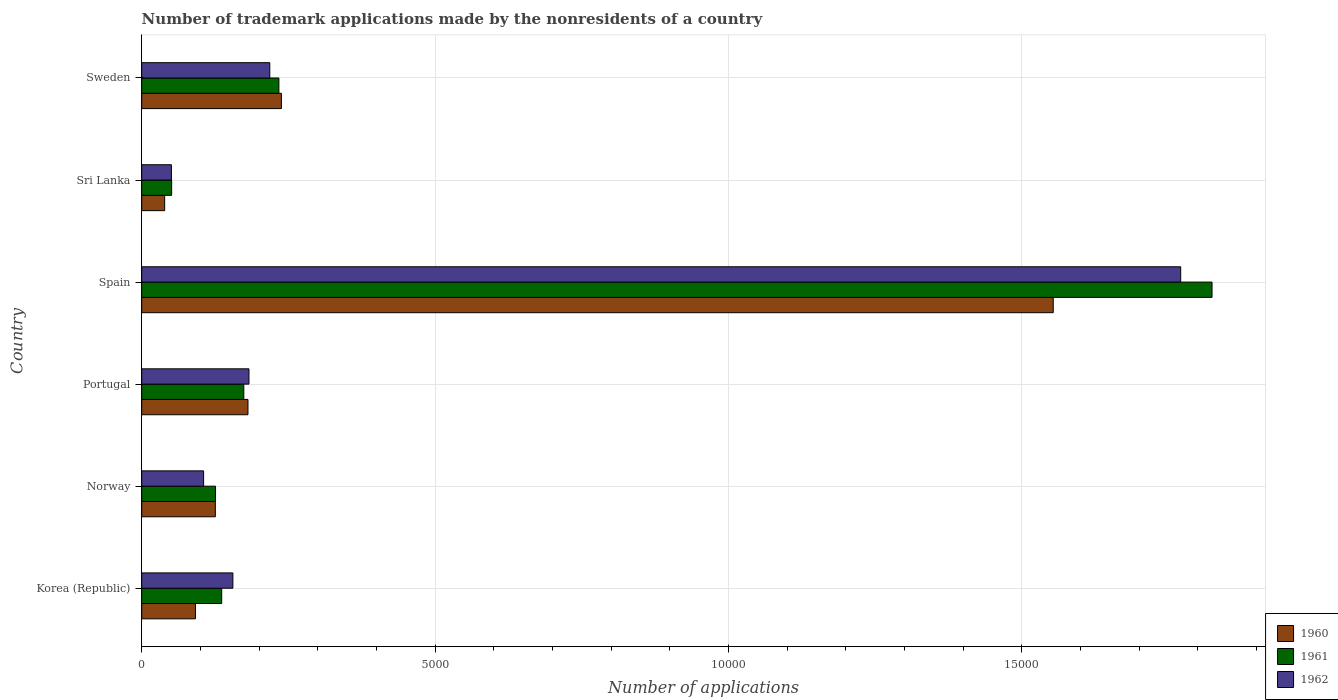How many different coloured bars are there?
Give a very brief answer. 3. How many groups of bars are there?
Your answer should be very brief. 6. Are the number of bars per tick equal to the number of legend labels?
Keep it short and to the point. Yes. Are the number of bars on each tick of the Y-axis equal?
Offer a terse response. Yes. How many bars are there on the 1st tick from the bottom?
Your response must be concise. 3. What is the number of trademark applications made by the nonresidents in 1962 in Sweden?
Make the answer very short. 2183. Across all countries, what is the maximum number of trademark applications made by the nonresidents in 1961?
Provide a short and direct response. 1.82e+04. Across all countries, what is the minimum number of trademark applications made by the nonresidents in 1962?
Offer a terse response. 506. In which country was the number of trademark applications made by the nonresidents in 1960 maximum?
Offer a very short reply. Spain. In which country was the number of trademark applications made by the nonresidents in 1961 minimum?
Your answer should be very brief. Sri Lanka. What is the total number of trademark applications made by the nonresidents in 1960 in the graph?
Ensure brevity in your answer.  2.23e+04. What is the difference between the number of trademark applications made by the nonresidents in 1961 in Norway and that in Spain?
Your answer should be very brief. -1.70e+04. What is the difference between the number of trademark applications made by the nonresidents in 1960 in Sri Lanka and the number of trademark applications made by the nonresidents in 1962 in Sweden?
Provide a short and direct response. -1792. What is the average number of trademark applications made by the nonresidents in 1960 per country?
Keep it short and to the point. 3715.17. What is the difference between the number of trademark applications made by the nonresidents in 1961 and number of trademark applications made by the nonresidents in 1962 in Spain?
Your answer should be very brief. 534. What is the ratio of the number of trademark applications made by the nonresidents in 1961 in Spain to that in Sri Lanka?
Keep it short and to the point. 35.77. Is the number of trademark applications made by the nonresidents in 1961 in Spain less than that in Sweden?
Ensure brevity in your answer.  No. What is the difference between the highest and the second highest number of trademark applications made by the nonresidents in 1961?
Keep it short and to the point. 1.59e+04. What is the difference between the highest and the lowest number of trademark applications made by the nonresidents in 1962?
Make the answer very short. 1.72e+04. What does the 1st bar from the top in Portugal represents?
Ensure brevity in your answer.  1962. What does the 3rd bar from the bottom in Spain represents?
Provide a short and direct response. 1962. Is it the case that in every country, the sum of the number of trademark applications made by the nonresidents in 1960 and number of trademark applications made by the nonresidents in 1962 is greater than the number of trademark applications made by the nonresidents in 1961?
Give a very brief answer. Yes. Are all the bars in the graph horizontal?
Your answer should be very brief. Yes. How many countries are there in the graph?
Provide a short and direct response. 6. Are the values on the major ticks of X-axis written in scientific E-notation?
Provide a short and direct response. No. Does the graph contain grids?
Keep it short and to the point. Yes. Where does the legend appear in the graph?
Make the answer very short. Bottom right. How are the legend labels stacked?
Offer a terse response. Vertical. What is the title of the graph?
Ensure brevity in your answer.  Number of trademark applications made by the nonresidents of a country. Does "1972" appear as one of the legend labels in the graph?
Make the answer very short. No. What is the label or title of the X-axis?
Your answer should be very brief. Number of applications. What is the Number of applications of 1960 in Korea (Republic)?
Ensure brevity in your answer.  916. What is the Number of applications in 1961 in Korea (Republic)?
Ensure brevity in your answer.  1363. What is the Number of applications of 1962 in Korea (Republic)?
Offer a terse response. 1554. What is the Number of applications of 1960 in Norway?
Your answer should be very brief. 1255. What is the Number of applications of 1961 in Norway?
Provide a succinct answer. 1258. What is the Number of applications in 1962 in Norway?
Give a very brief answer. 1055. What is the Number of applications of 1960 in Portugal?
Provide a succinct answer. 1811. What is the Number of applications of 1961 in Portugal?
Provide a succinct answer. 1740. What is the Number of applications of 1962 in Portugal?
Keep it short and to the point. 1828. What is the Number of applications of 1960 in Spain?
Offer a terse response. 1.55e+04. What is the Number of applications in 1961 in Spain?
Offer a terse response. 1.82e+04. What is the Number of applications in 1962 in Spain?
Keep it short and to the point. 1.77e+04. What is the Number of applications in 1960 in Sri Lanka?
Provide a short and direct response. 391. What is the Number of applications of 1961 in Sri Lanka?
Your answer should be very brief. 510. What is the Number of applications in 1962 in Sri Lanka?
Your answer should be compact. 506. What is the Number of applications of 1960 in Sweden?
Make the answer very short. 2381. What is the Number of applications of 1961 in Sweden?
Provide a succinct answer. 2338. What is the Number of applications in 1962 in Sweden?
Make the answer very short. 2183. Across all countries, what is the maximum Number of applications of 1960?
Ensure brevity in your answer.  1.55e+04. Across all countries, what is the maximum Number of applications in 1961?
Keep it short and to the point. 1.82e+04. Across all countries, what is the maximum Number of applications of 1962?
Provide a succinct answer. 1.77e+04. Across all countries, what is the minimum Number of applications of 1960?
Keep it short and to the point. 391. Across all countries, what is the minimum Number of applications in 1961?
Offer a terse response. 510. Across all countries, what is the minimum Number of applications in 1962?
Provide a short and direct response. 506. What is the total Number of applications in 1960 in the graph?
Offer a terse response. 2.23e+04. What is the total Number of applications in 1961 in the graph?
Make the answer very short. 2.55e+04. What is the total Number of applications of 1962 in the graph?
Provide a short and direct response. 2.48e+04. What is the difference between the Number of applications of 1960 in Korea (Republic) and that in Norway?
Your answer should be very brief. -339. What is the difference between the Number of applications in 1961 in Korea (Republic) and that in Norway?
Ensure brevity in your answer.  105. What is the difference between the Number of applications in 1962 in Korea (Republic) and that in Norway?
Provide a short and direct response. 499. What is the difference between the Number of applications in 1960 in Korea (Republic) and that in Portugal?
Offer a very short reply. -895. What is the difference between the Number of applications in 1961 in Korea (Republic) and that in Portugal?
Offer a very short reply. -377. What is the difference between the Number of applications in 1962 in Korea (Republic) and that in Portugal?
Your answer should be very brief. -274. What is the difference between the Number of applications of 1960 in Korea (Republic) and that in Spain?
Provide a short and direct response. -1.46e+04. What is the difference between the Number of applications of 1961 in Korea (Republic) and that in Spain?
Give a very brief answer. -1.69e+04. What is the difference between the Number of applications of 1962 in Korea (Republic) and that in Spain?
Offer a very short reply. -1.62e+04. What is the difference between the Number of applications in 1960 in Korea (Republic) and that in Sri Lanka?
Give a very brief answer. 525. What is the difference between the Number of applications of 1961 in Korea (Republic) and that in Sri Lanka?
Give a very brief answer. 853. What is the difference between the Number of applications in 1962 in Korea (Republic) and that in Sri Lanka?
Your answer should be compact. 1048. What is the difference between the Number of applications of 1960 in Korea (Republic) and that in Sweden?
Ensure brevity in your answer.  -1465. What is the difference between the Number of applications in 1961 in Korea (Republic) and that in Sweden?
Keep it short and to the point. -975. What is the difference between the Number of applications of 1962 in Korea (Republic) and that in Sweden?
Ensure brevity in your answer.  -629. What is the difference between the Number of applications in 1960 in Norway and that in Portugal?
Ensure brevity in your answer.  -556. What is the difference between the Number of applications in 1961 in Norway and that in Portugal?
Provide a succinct answer. -482. What is the difference between the Number of applications in 1962 in Norway and that in Portugal?
Keep it short and to the point. -773. What is the difference between the Number of applications of 1960 in Norway and that in Spain?
Your answer should be very brief. -1.43e+04. What is the difference between the Number of applications of 1961 in Norway and that in Spain?
Make the answer very short. -1.70e+04. What is the difference between the Number of applications in 1962 in Norway and that in Spain?
Your answer should be very brief. -1.67e+04. What is the difference between the Number of applications of 1960 in Norway and that in Sri Lanka?
Ensure brevity in your answer.  864. What is the difference between the Number of applications of 1961 in Norway and that in Sri Lanka?
Offer a very short reply. 748. What is the difference between the Number of applications of 1962 in Norway and that in Sri Lanka?
Your answer should be compact. 549. What is the difference between the Number of applications of 1960 in Norway and that in Sweden?
Your response must be concise. -1126. What is the difference between the Number of applications of 1961 in Norway and that in Sweden?
Offer a terse response. -1080. What is the difference between the Number of applications of 1962 in Norway and that in Sweden?
Provide a succinct answer. -1128. What is the difference between the Number of applications of 1960 in Portugal and that in Spain?
Ensure brevity in your answer.  -1.37e+04. What is the difference between the Number of applications in 1961 in Portugal and that in Spain?
Make the answer very short. -1.65e+04. What is the difference between the Number of applications of 1962 in Portugal and that in Spain?
Give a very brief answer. -1.59e+04. What is the difference between the Number of applications in 1960 in Portugal and that in Sri Lanka?
Give a very brief answer. 1420. What is the difference between the Number of applications in 1961 in Portugal and that in Sri Lanka?
Your answer should be very brief. 1230. What is the difference between the Number of applications of 1962 in Portugal and that in Sri Lanka?
Give a very brief answer. 1322. What is the difference between the Number of applications in 1960 in Portugal and that in Sweden?
Provide a short and direct response. -570. What is the difference between the Number of applications of 1961 in Portugal and that in Sweden?
Give a very brief answer. -598. What is the difference between the Number of applications of 1962 in Portugal and that in Sweden?
Provide a short and direct response. -355. What is the difference between the Number of applications of 1960 in Spain and that in Sri Lanka?
Ensure brevity in your answer.  1.51e+04. What is the difference between the Number of applications of 1961 in Spain and that in Sri Lanka?
Keep it short and to the point. 1.77e+04. What is the difference between the Number of applications of 1962 in Spain and that in Sri Lanka?
Offer a terse response. 1.72e+04. What is the difference between the Number of applications in 1960 in Spain and that in Sweden?
Offer a terse response. 1.32e+04. What is the difference between the Number of applications of 1961 in Spain and that in Sweden?
Offer a very short reply. 1.59e+04. What is the difference between the Number of applications in 1962 in Spain and that in Sweden?
Keep it short and to the point. 1.55e+04. What is the difference between the Number of applications in 1960 in Sri Lanka and that in Sweden?
Give a very brief answer. -1990. What is the difference between the Number of applications in 1961 in Sri Lanka and that in Sweden?
Offer a very short reply. -1828. What is the difference between the Number of applications in 1962 in Sri Lanka and that in Sweden?
Keep it short and to the point. -1677. What is the difference between the Number of applications of 1960 in Korea (Republic) and the Number of applications of 1961 in Norway?
Make the answer very short. -342. What is the difference between the Number of applications of 1960 in Korea (Republic) and the Number of applications of 1962 in Norway?
Ensure brevity in your answer.  -139. What is the difference between the Number of applications in 1961 in Korea (Republic) and the Number of applications in 1962 in Norway?
Ensure brevity in your answer.  308. What is the difference between the Number of applications in 1960 in Korea (Republic) and the Number of applications in 1961 in Portugal?
Your answer should be very brief. -824. What is the difference between the Number of applications in 1960 in Korea (Republic) and the Number of applications in 1962 in Portugal?
Offer a terse response. -912. What is the difference between the Number of applications of 1961 in Korea (Republic) and the Number of applications of 1962 in Portugal?
Give a very brief answer. -465. What is the difference between the Number of applications of 1960 in Korea (Republic) and the Number of applications of 1961 in Spain?
Give a very brief answer. -1.73e+04. What is the difference between the Number of applications of 1960 in Korea (Republic) and the Number of applications of 1962 in Spain?
Provide a succinct answer. -1.68e+04. What is the difference between the Number of applications in 1961 in Korea (Republic) and the Number of applications in 1962 in Spain?
Provide a succinct answer. -1.63e+04. What is the difference between the Number of applications in 1960 in Korea (Republic) and the Number of applications in 1961 in Sri Lanka?
Give a very brief answer. 406. What is the difference between the Number of applications of 1960 in Korea (Republic) and the Number of applications of 1962 in Sri Lanka?
Offer a terse response. 410. What is the difference between the Number of applications in 1961 in Korea (Republic) and the Number of applications in 1962 in Sri Lanka?
Give a very brief answer. 857. What is the difference between the Number of applications in 1960 in Korea (Republic) and the Number of applications in 1961 in Sweden?
Your answer should be compact. -1422. What is the difference between the Number of applications in 1960 in Korea (Republic) and the Number of applications in 1962 in Sweden?
Your response must be concise. -1267. What is the difference between the Number of applications in 1961 in Korea (Republic) and the Number of applications in 1962 in Sweden?
Provide a short and direct response. -820. What is the difference between the Number of applications of 1960 in Norway and the Number of applications of 1961 in Portugal?
Make the answer very short. -485. What is the difference between the Number of applications in 1960 in Norway and the Number of applications in 1962 in Portugal?
Your response must be concise. -573. What is the difference between the Number of applications of 1961 in Norway and the Number of applications of 1962 in Portugal?
Provide a short and direct response. -570. What is the difference between the Number of applications in 1960 in Norway and the Number of applications in 1961 in Spain?
Your answer should be very brief. -1.70e+04. What is the difference between the Number of applications in 1960 in Norway and the Number of applications in 1962 in Spain?
Make the answer very short. -1.65e+04. What is the difference between the Number of applications in 1961 in Norway and the Number of applications in 1962 in Spain?
Offer a terse response. -1.65e+04. What is the difference between the Number of applications of 1960 in Norway and the Number of applications of 1961 in Sri Lanka?
Your response must be concise. 745. What is the difference between the Number of applications in 1960 in Norway and the Number of applications in 1962 in Sri Lanka?
Offer a very short reply. 749. What is the difference between the Number of applications in 1961 in Norway and the Number of applications in 1962 in Sri Lanka?
Your response must be concise. 752. What is the difference between the Number of applications of 1960 in Norway and the Number of applications of 1961 in Sweden?
Offer a very short reply. -1083. What is the difference between the Number of applications of 1960 in Norway and the Number of applications of 1962 in Sweden?
Keep it short and to the point. -928. What is the difference between the Number of applications in 1961 in Norway and the Number of applications in 1962 in Sweden?
Give a very brief answer. -925. What is the difference between the Number of applications in 1960 in Portugal and the Number of applications in 1961 in Spain?
Give a very brief answer. -1.64e+04. What is the difference between the Number of applications in 1960 in Portugal and the Number of applications in 1962 in Spain?
Make the answer very short. -1.59e+04. What is the difference between the Number of applications of 1961 in Portugal and the Number of applications of 1962 in Spain?
Provide a succinct answer. -1.60e+04. What is the difference between the Number of applications in 1960 in Portugal and the Number of applications in 1961 in Sri Lanka?
Your response must be concise. 1301. What is the difference between the Number of applications of 1960 in Portugal and the Number of applications of 1962 in Sri Lanka?
Offer a very short reply. 1305. What is the difference between the Number of applications in 1961 in Portugal and the Number of applications in 1962 in Sri Lanka?
Your answer should be very brief. 1234. What is the difference between the Number of applications of 1960 in Portugal and the Number of applications of 1961 in Sweden?
Keep it short and to the point. -527. What is the difference between the Number of applications of 1960 in Portugal and the Number of applications of 1962 in Sweden?
Keep it short and to the point. -372. What is the difference between the Number of applications of 1961 in Portugal and the Number of applications of 1962 in Sweden?
Your answer should be compact. -443. What is the difference between the Number of applications in 1960 in Spain and the Number of applications in 1961 in Sri Lanka?
Your answer should be compact. 1.50e+04. What is the difference between the Number of applications in 1960 in Spain and the Number of applications in 1962 in Sri Lanka?
Give a very brief answer. 1.50e+04. What is the difference between the Number of applications of 1961 in Spain and the Number of applications of 1962 in Sri Lanka?
Offer a terse response. 1.77e+04. What is the difference between the Number of applications of 1960 in Spain and the Number of applications of 1961 in Sweden?
Ensure brevity in your answer.  1.32e+04. What is the difference between the Number of applications in 1960 in Spain and the Number of applications in 1962 in Sweden?
Keep it short and to the point. 1.34e+04. What is the difference between the Number of applications in 1961 in Spain and the Number of applications in 1962 in Sweden?
Your answer should be compact. 1.61e+04. What is the difference between the Number of applications in 1960 in Sri Lanka and the Number of applications in 1961 in Sweden?
Offer a very short reply. -1947. What is the difference between the Number of applications in 1960 in Sri Lanka and the Number of applications in 1962 in Sweden?
Offer a terse response. -1792. What is the difference between the Number of applications in 1961 in Sri Lanka and the Number of applications in 1962 in Sweden?
Ensure brevity in your answer.  -1673. What is the average Number of applications in 1960 per country?
Your response must be concise. 3715.17. What is the average Number of applications in 1961 per country?
Give a very brief answer. 4242.17. What is the average Number of applications in 1962 per country?
Keep it short and to the point. 4139.33. What is the difference between the Number of applications in 1960 and Number of applications in 1961 in Korea (Republic)?
Offer a terse response. -447. What is the difference between the Number of applications in 1960 and Number of applications in 1962 in Korea (Republic)?
Offer a terse response. -638. What is the difference between the Number of applications of 1961 and Number of applications of 1962 in Korea (Republic)?
Provide a short and direct response. -191. What is the difference between the Number of applications in 1960 and Number of applications in 1961 in Norway?
Provide a short and direct response. -3. What is the difference between the Number of applications of 1960 and Number of applications of 1962 in Norway?
Give a very brief answer. 200. What is the difference between the Number of applications in 1961 and Number of applications in 1962 in Norway?
Your answer should be compact. 203. What is the difference between the Number of applications in 1960 and Number of applications in 1962 in Portugal?
Make the answer very short. -17. What is the difference between the Number of applications in 1961 and Number of applications in 1962 in Portugal?
Provide a short and direct response. -88. What is the difference between the Number of applications in 1960 and Number of applications in 1961 in Spain?
Make the answer very short. -2707. What is the difference between the Number of applications in 1960 and Number of applications in 1962 in Spain?
Keep it short and to the point. -2173. What is the difference between the Number of applications of 1961 and Number of applications of 1962 in Spain?
Ensure brevity in your answer.  534. What is the difference between the Number of applications of 1960 and Number of applications of 1961 in Sri Lanka?
Ensure brevity in your answer.  -119. What is the difference between the Number of applications in 1960 and Number of applications in 1962 in Sri Lanka?
Offer a terse response. -115. What is the difference between the Number of applications of 1961 and Number of applications of 1962 in Sri Lanka?
Provide a short and direct response. 4. What is the difference between the Number of applications in 1960 and Number of applications in 1962 in Sweden?
Provide a succinct answer. 198. What is the difference between the Number of applications of 1961 and Number of applications of 1962 in Sweden?
Your response must be concise. 155. What is the ratio of the Number of applications in 1960 in Korea (Republic) to that in Norway?
Offer a very short reply. 0.73. What is the ratio of the Number of applications of 1961 in Korea (Republic) to that in Norway?
Give a very brief answer. 1.08. What is the ratio of the Number of applications in 1962 in Korea (Republic) to that in Norway?
Keep it short and to the point. 1.47. What is the ratio of the Number of applications of 1960 in Korea (Republic) to that in Portugal?
Your response must be concise. 0.51. What is the ratio of the Number of applications in 1961 in Korea (Republic) to that in Portugal?
Your response must be concise. 0.78. What is the ratio of the Number of applications in 1962 in Korea (Republic) to that in Portugal?
Your response must be concise. 0.85. What is the ratio of the Number of applications of 1960 in Korea (Republic) to that in Spain?
Offer a terse response. 0.06. What is the ratio of the Number of applications in 1961 in Korea (Republic) to that in Spain?
Provide a succinct answer. 0.07. What is the ratio of the Number of applications in 1962 in Korea (Republic) to that in Spain?
Offer a very short reply. 0.09. What is the ratio of the Number of applications in 1960 in Korea (Republic) to that in Sri Lanka?
Keep it short and to the point. 2.34. What is the ratio of the Number of applications of 1961 in Korea (Republic) to that in Sri Lanka?
Offer a very short reply. 2.67. What is the ratio of the Number of applications in 1962 in Korea (Republic) to that in Sri Lanka?
Ensure brevity in your answer.  3.07. What is the ratio of the Number of applications in 1960 in Korea (Republic) to that in Sweden?
Provide a succinct answer. 0.38. What is the ratio of the Number of applications in 1961 in Korea (Republic) to that in Sweden?
Offer a very short reply. 0.58. What is the ratio of the Number of applications of 1962 in Korea (Republic) to that in Sweden?
Keep it short and to the point. 0.71. What is the ratio of the Number of applications in 1960 in Norway to that in Portugal?
Provide a succinct answer. 0.69. What is the ratio of the Number of applications of 1961 in Norway to that in Portugal?
Provide a short and direct response. 0.72. What is the ratio of the Number of applications in 1962 in Norway to that in Portugal?
Keep it short and to the point. 0.58. What is the ratio of the Number of applications in 1960 in Norway to that in Spain?
Ensure brevity in your answer.  0.08. What is the ratio of the Number of applications in 1961 in Norway to that in Spain?
Your answer should be very brief. 0.07. What is the ratio of the Number of applications of 1962 in Norway to that in Spain?
Provide a succinct answer. 0.06. What is the ratio of the Number of applications of 1960 in Norway to that in Sri Lanka?
Keep it short and to the point. 3.21. What is the ratio of the Number of applications of 1961 in Norway to that in Sri Lanka?
Your answer should be very brief. 2.47. What is the ratio of the Number of applications in 1962 in Norway to that in Sri Lanka?
Provide a succinct answer. 2.08. What is the ratio of the Number of applications of 1960 in Norway to that in Sweden?
Offer a terse response. 0.53. What is the ratio of the Number of applications in 1961 in Norway to that in Sweden?
Give a very brief answer. 0.54. What is the ratio of the Number of applications of 1962 in Norway to that in Sweden?
Keep it short and to the point. 0.48. What is the ratio of the Number of applications of 1960 in Portugal to that in Spain?
Provide a short and direct response. 0.12. What is the ratio of the Number of applications in 1961 in Portugal to that in Spain?
Give a very brief answer. 0.1. What is the ratio of the Number of applications of 1962 in Portugal to that in Spain?
Make the answer very short. 0.1. What is the ratio of the Number of applications in 1960 in Portugal to that in Sri Lanka?
Provide a short and direct response. 4.63. What is the ratio of the Number of applications in 1961 in Portugal to that in Sri Lanka?
Offer a terse response. 3.41. What is the ratio of the Number of applications in 1962 in Portugal to that in Sri Lanka?
Provide a short and direct response. 3.61. What is the ratio of the Number of applications in 1960 in Portugal to that in Sweden?
Ensure brevity in your answer.  0.76. What is the ratio of the Number of applications of 1961 in Portugal to that in Sweden?
Your answer should be compact. 0.74. What is the ratio of the Number of applications of 1962 in Portugal to that in Sweden?
Provide a succinct answer. 0.84. What is the ratio of the Number of applications of 1960 in Spain to that in Sri Lanka?
Make the answer very short. 39.74. What is the ratio of the Number of applications in 1961 in Spain to that in Sri Lanka?
Offer a terse response. 35.77. What is the ratio of the Number of applications in 1962 in Spain to that in Sri Lanka?
Provide a succinct answer. 35. What is the ratio of the Number of applications in 1960 in Spain to that in Sweden?
Offer a terse response. 6.53. What is the ratio of the Number of applications of 1961 in Spain to that in Sweden?
Offer a very short reply. 7.8. What is the ratio of the Number of applications of 1962 in Spain to that in Sweden?
Your response must be concise. 8.11. What is the ratio of the Number of applications in 1960 in Sri Lanka to that in Sweden?
Keep it short and to the point. 0.16. What is the ratio of the Number of applications of 1961 in Sri Lanka to that in Sweden?
Provide a short and direct response. 0.22. What is the ratio of the Number of applications in 1962 in Sri Lanka to that in Sweden?
Ensure brevity in your answer.  0.23. What is the difference between the highest and the second highest Number of applications in 1960?
Provide a short and direct response. 1.32e+04. What is the difference between the highest and the second highest Number of applications in 1961?
Offer a terse response. 1.59e+04. What is the difference between the highest and the second highest Number of applications in 1962?
Your response must be concise. 1.55e+04. What is the difference between the highest and the lowest Number of applications of 1960?
Your answer should be very brief. 1.51e+04. What is the difference between the highest and the lowest Number of applications in 1961?
Your answer should be compact. 1.77e+04. What is the difference between the highest and the lowest Number of applications of 1962?
Provide a succinct answer. 1.72e+04. 